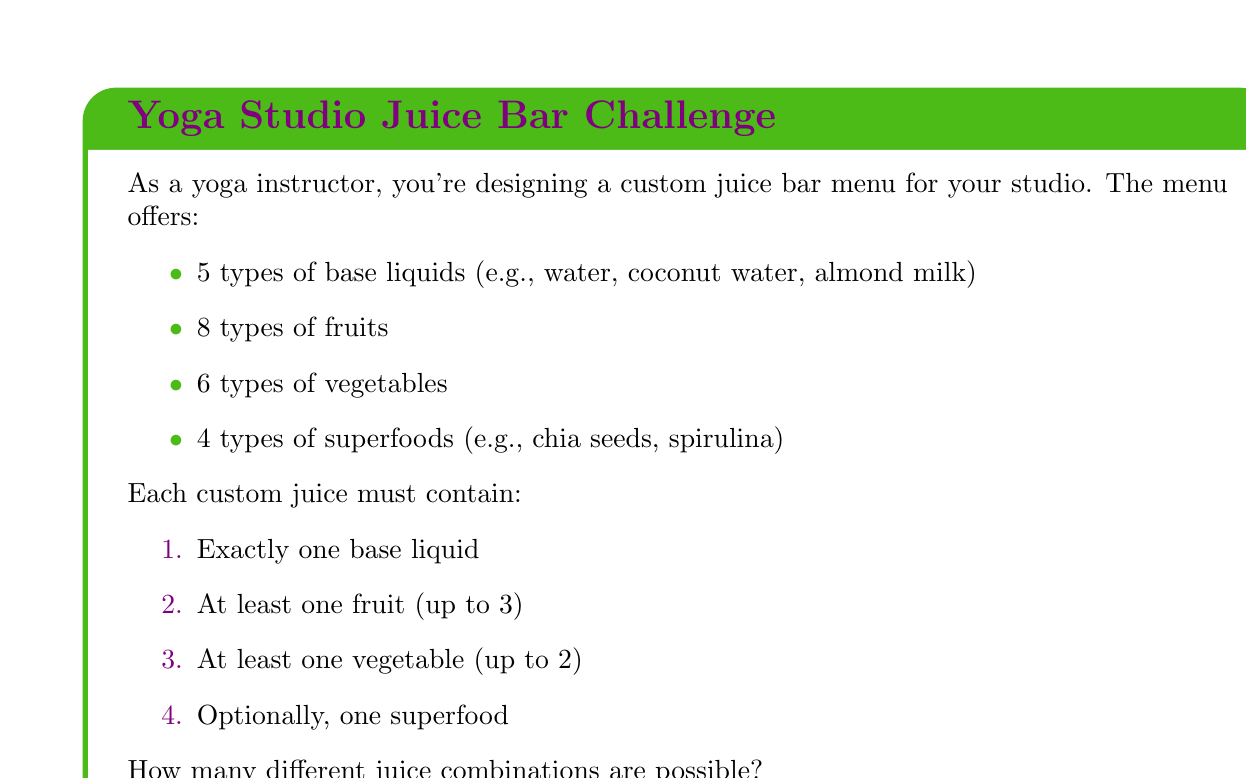Can you solve this math problem? Let's break this down step-by-step:

1) First, let's consider the base liquid. There are 5 choices, and we must choose exactly one:
   $${5 \choose 1} = 5$$

2) For fruits, we can choose 1, 2, or 3 out of 8:
   $${8 \choose 1} + {8 \choose 2} + {8 \choose 3} = 8 + 28 + 56 = 92$$

3) For vegetables, we can choose 1 or 2 out of 6:
   $${6 \choose 1} + {6 \choose 2} = 6 + 15 = 21$$

4) For superfoods, we have two options: either choose one or none:
   $${4 \choose 1} + {4 \choose 0} = 4 + 1 = 5$$

5) Now, according to the multiplication principle, we multiply these numbers:

   $$5 \times 92 \times 21 \times 5 = 48,300$$

This gives us the total number of possible juice combinations.
Answer: 48,300 combinations 